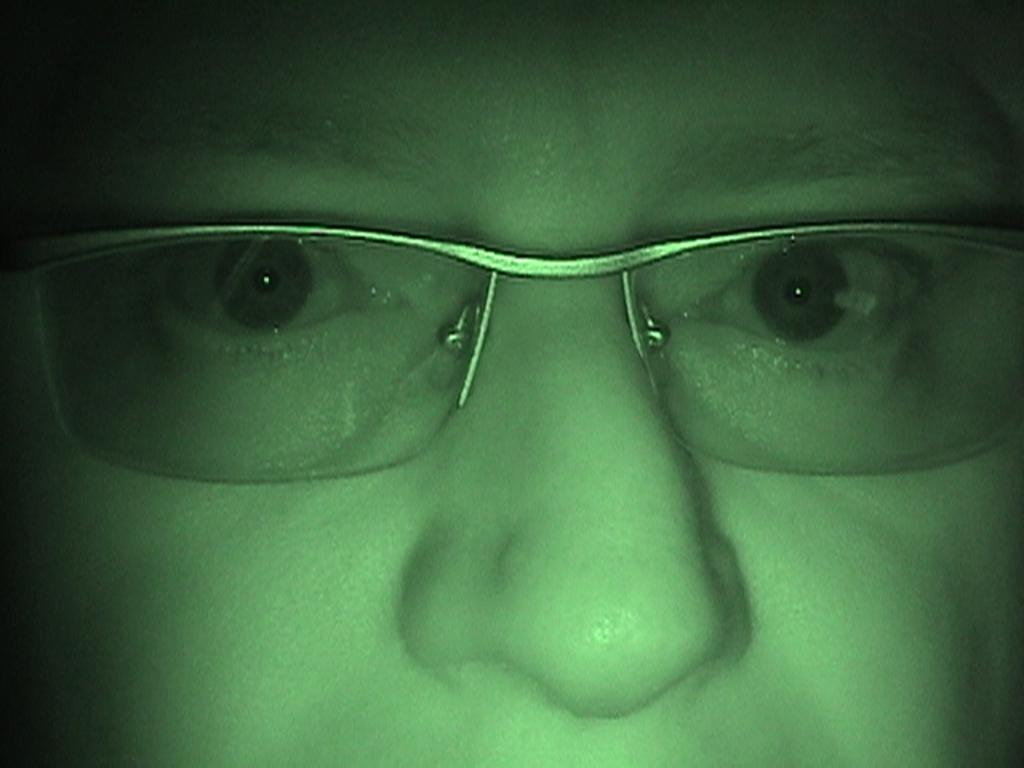What is the main subject of the image? There is a person in the image. What part of the person is visible in the image? Only the person's face is visible in the image. What accessory is the person wearing in the image? The person is wearing goggles. What facial features can be seen on the person in the image? The person has a nose and eyes. What type of comb does the person's mother use in the image? There is no mention of a mother or a comb in the image, so we cannot answer this question. 